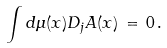Convert formula to latex. <formula><loc_0><loc_0><loc_500><loc_500>\int d \mu ( x ) D _ { j } A ( x ) \, = \, 0 \, .</formula> 